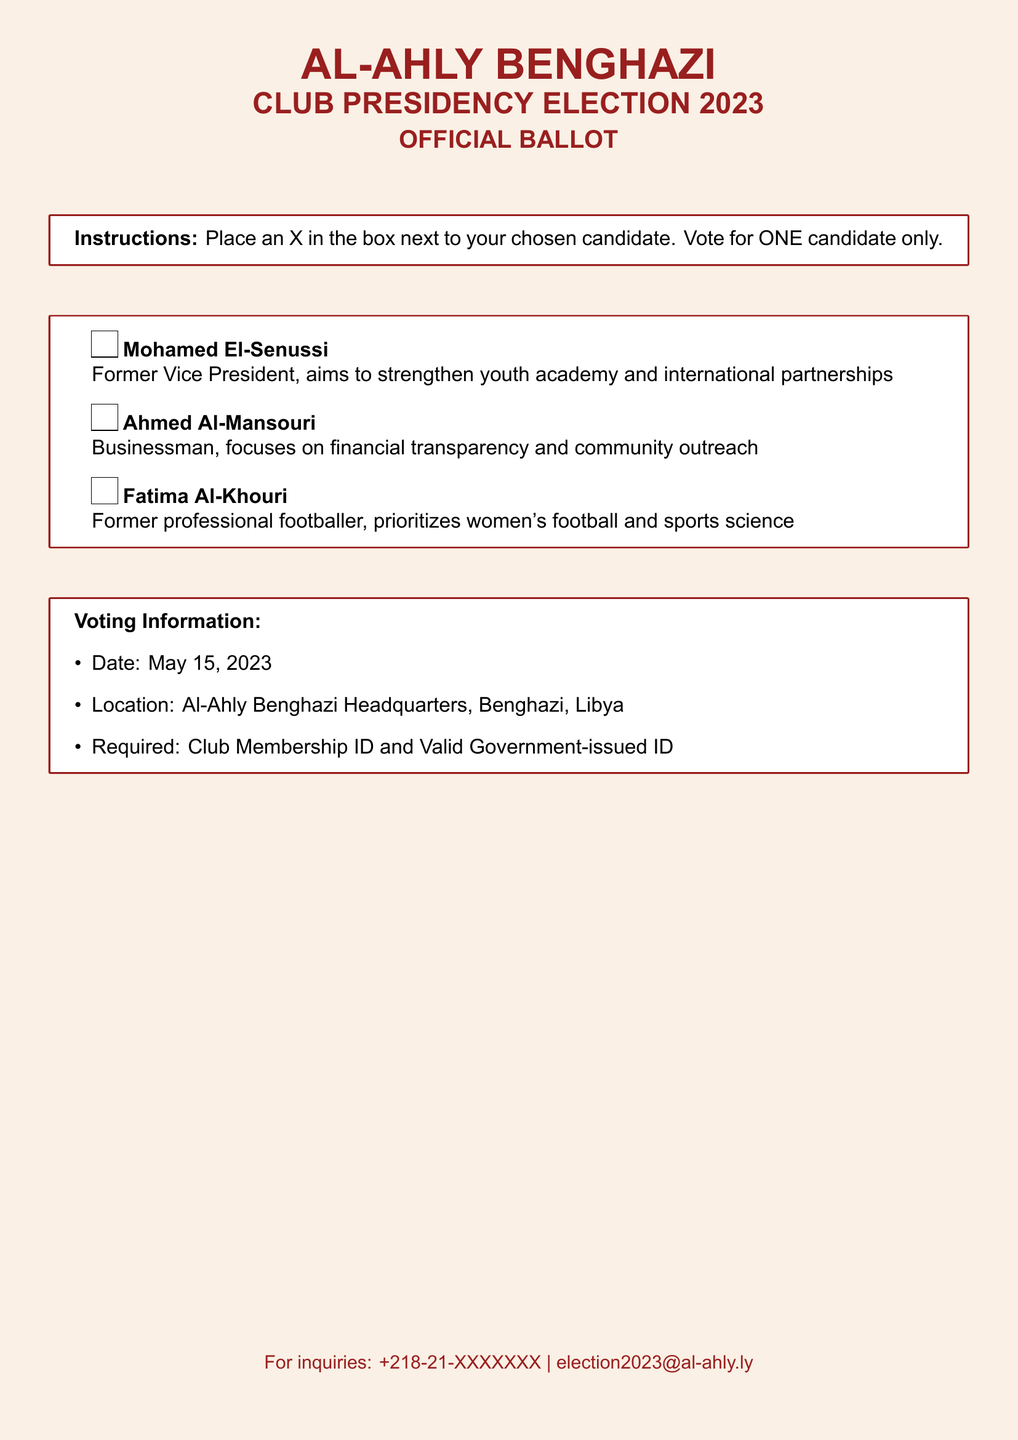What is the election date? The election date is clearly stated in the voting information section of the document.
Answer: May 15, 2023 Who is the candidate focusing on women's football? The manifesto of each candidate includes their focus areas, which reveals that one candidate is prioritizing women's football.
Answer: Fatima Al-Khouri Where is the voting location? The location for the voting is indicated in the voting information section of the document.
Answer: Al-Ahly Benghazi Headquarters, Benghazi, Libya What is required to vote? The document specifies requirements needed for voting, which includes the necessary identification.
Answer: Club Membership ID and Valid Government-issued ID Who aims to strengthen international partnerships? The candidates' manifestos highlight their goals, specifying one candidate's aim related to international partnerships.
Answer: Mohamed El-Senussi How many candidates are listed? The number of candidates is presented in the itemized list in the document, showing all participants.
Answer: Three What is Ahmed Al-Mansouri's focus? The focus of each candidate is summarized in their profiles, identifying what Ahmed Al-Mansouri aims to achieve.
Answer: Financial transparency and community outreach What color is used for the document title? The document uses a specific color for the titles, which can be identified in the formatting section.
Answer: Alhambra 